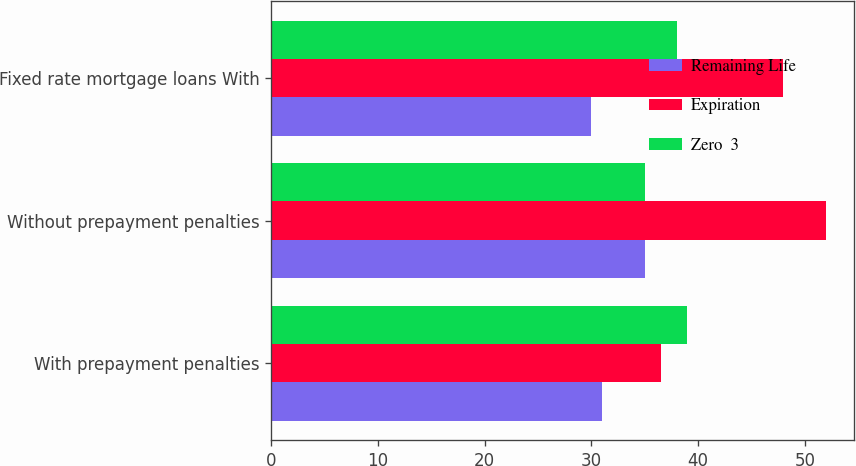Convert chart. <chart><loc_0><loc_0><loc_500><loc_500><stacked_bar_chart><ecel><fcel>With prepayment penalties<fcel>Without prepayment penalties<fcel>Fixed rate mortgage loans With<nl><fcel>Remaining Life<fcel>31<fcel>35<fcel>30<nl><fcel>Expiration<fcel>36.5<fcel>52<fcel>48<nl><fcel>Zero  3<fcel>39<fcel>35<fcel>38<nl></chart> 